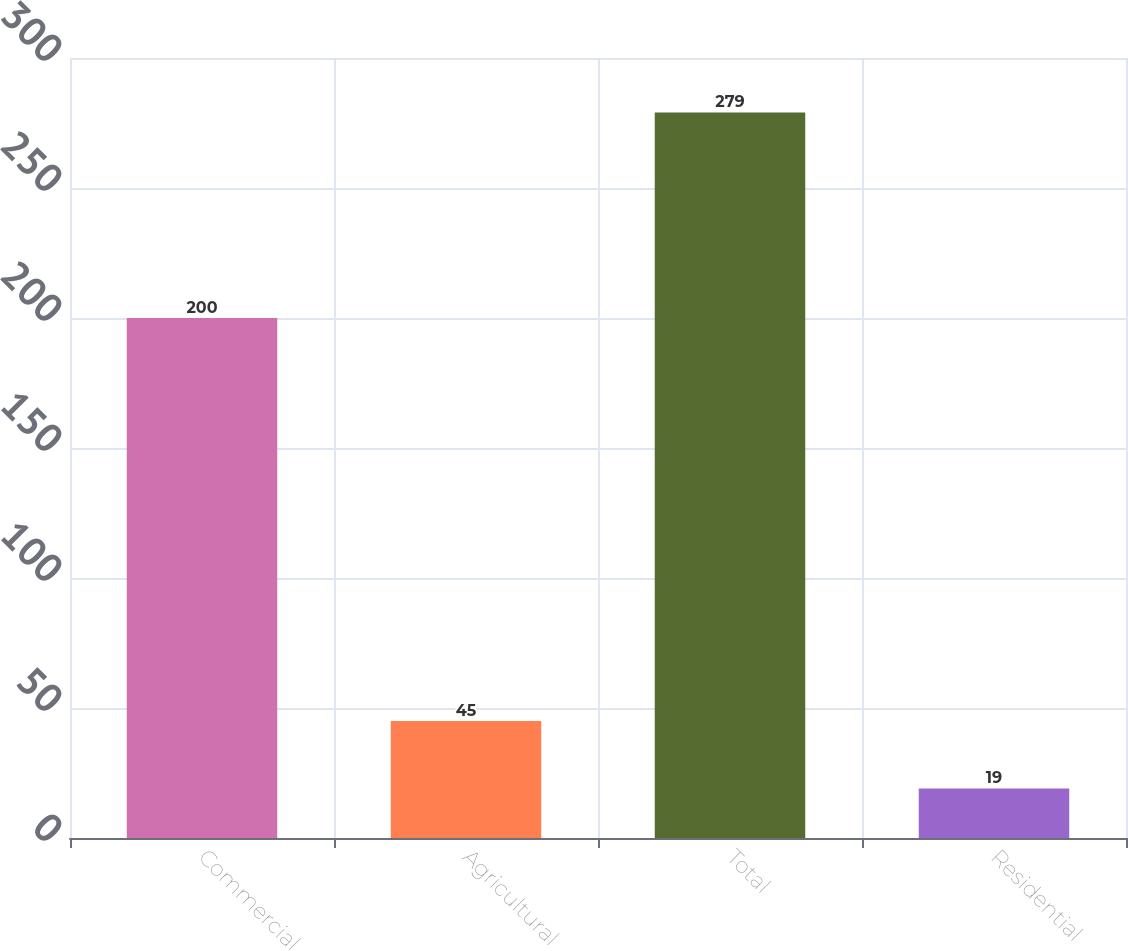Convert chart to OTSL. <chart><loc_0><loc_0><loc_500><loc_500><bar_chart><fcel>Commercial<fcel>Agricultural<fcel>Total<fcel>Residential<nl><fcel>200<fcel>45<fcel>279<fcel>19<nl></chart> 